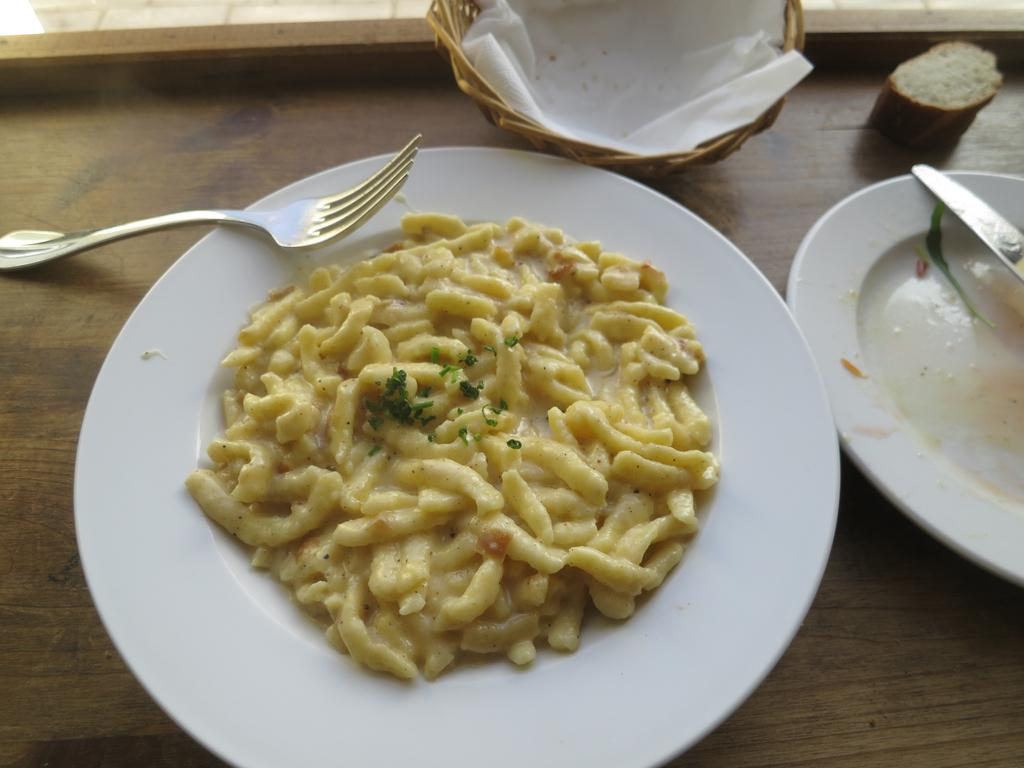What is on the plate in the image? There is food in the plate. Can you describe the appearance of the food? The food has cream and green colors. What utensils are present in the image? There is a fork and knife in the image. Where is the plate located? The plate is on a table. What is the color of the table? The table has a brown color. What type of metal is the approval stamp made of in the image? There is no approval stamp present in the image, so it is not possible to determine the type of metal it might be made of. 